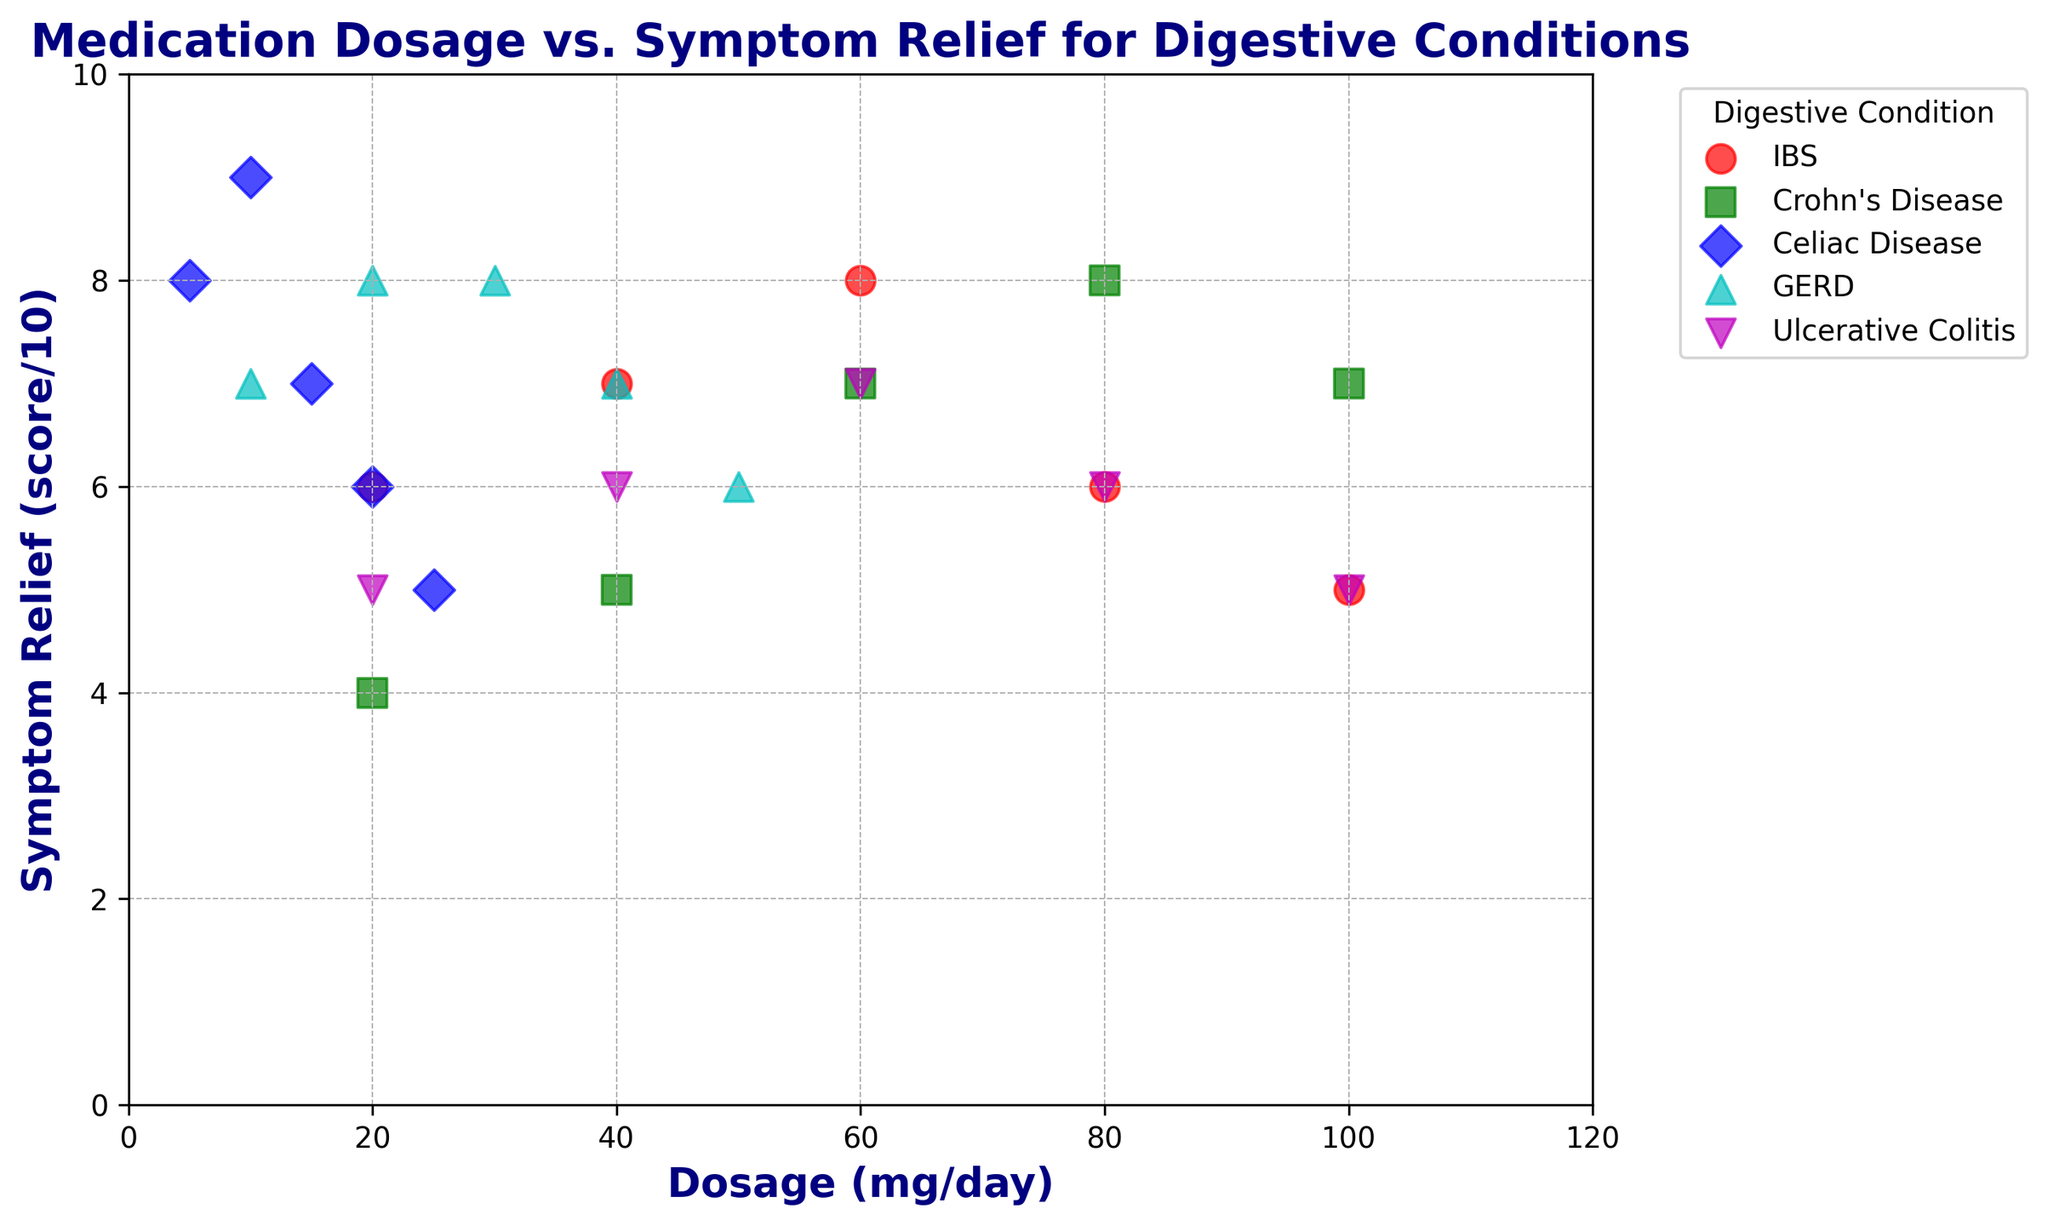What's the average symptom relief score for IBS at different dosages? To find the average symptom relief score for IBS, we sum up the scores and divide by the number of data points. The scores are 6, 7, 8, 6, 5. The sum is 32, and there are 5 data points. Therefore, the average is 32 / 5.
Answer: 6.4 Which condition shows the highest symptom relief score at the lowest dosage? By looking at the scatter plot, we can see that the lowest dosage for different conditions is: IBS (20 mg/day, score 6), Crohn's Disease (20 mg/day, score 4), Celiac Disease (5 mg/day, score 8), GERD (10 mg/day, score 7), and Ulcerative Colitis (20 mg/day, score 5). Celiac Disease shows the highest symptom relief score of 8 at a dosage of 5 mg/day.
Answer: Celiac Disease What is the general trend of symptom relief scores for Crohn's Disease as the dosage increases? By examining the scatter plot for Crohn's Disease, we see the symptom relief scores are 4, 5, 7, 8, and 7 for dosages of 20, 40, 60, 80, and 100 mg/day respectively. The scores generally increase until 80 mg/day and slightly decrease afterward.
Answer: Increasing then slightly decreasing How do the symptom relief scores for IBS at 60 mg/day compare to those for GERD at 30 mg/day? For IBS at 60 mg/day, the symptom relief score is 8. For GERD at 30 mg/day, the symptom relief score is also 8. Hence, the symptom relief scores are equal.
Answer: Equal Which conditions have a decreasing trend in symptom relief scores as the dosage increases? To determine the decreasing trend, we inspect the scatter plot for each condition. IBS and Celiac Disease show a clear decreasing trend in symptom relief scores as the dosage increases from certain points. IBS decreases after 60 mg/day and Celiac Disease consistently decreases after 10 mg/day.
Answer: IBS, Celiac Disease What is the difference in symptom relief scores between the highest and lowest dosage for GERD? For GERD, the highest dosage is 50 mg/day with a score of 6, and the lowest dosage is 10 mg/day with a score of 7. The difference in symptom relief scores is 7 - 6.
Answer: 1 For ulcerative colitis, what is the total sum of the symptom relief scores across all dosages? The symptom relief scores for ulcerative colitis are 5, 6, 7, 6, and 5 for dosages of 20, 40, 60, 80, and 100 mg/day respectively. Adding these, we get 5 + 6 + 7 + 6 + 5.
Answer: 29 Which condition has the most consistent symptom relief scores across different dosages? By examining the scatter plot, GERD shows symptom relief scores of 7, 8, 8, 7, and 6 across dosages of 10, 20, 30, 40, and 50 mg/day. These scores are relatively consistent as the changes are minimal.
Answer: GERD 